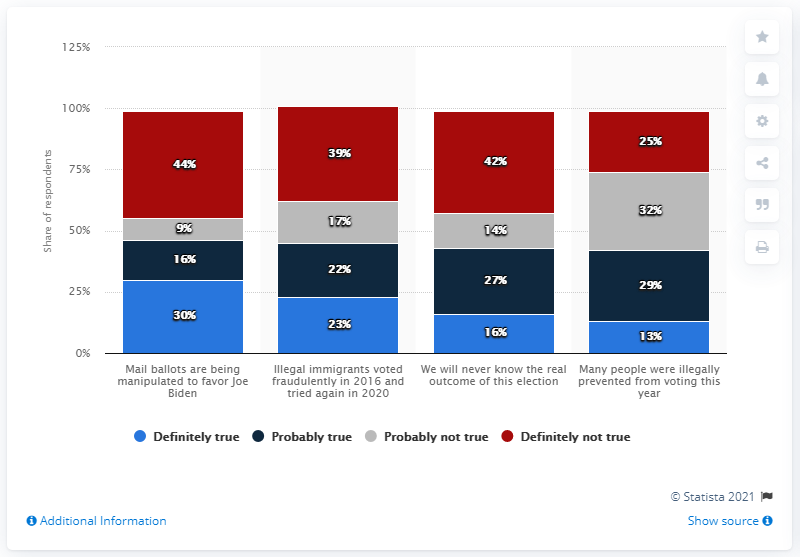Specify some key components in this picture. The sum of all the red bar values is 150. The highest value in the red bar is 44. 